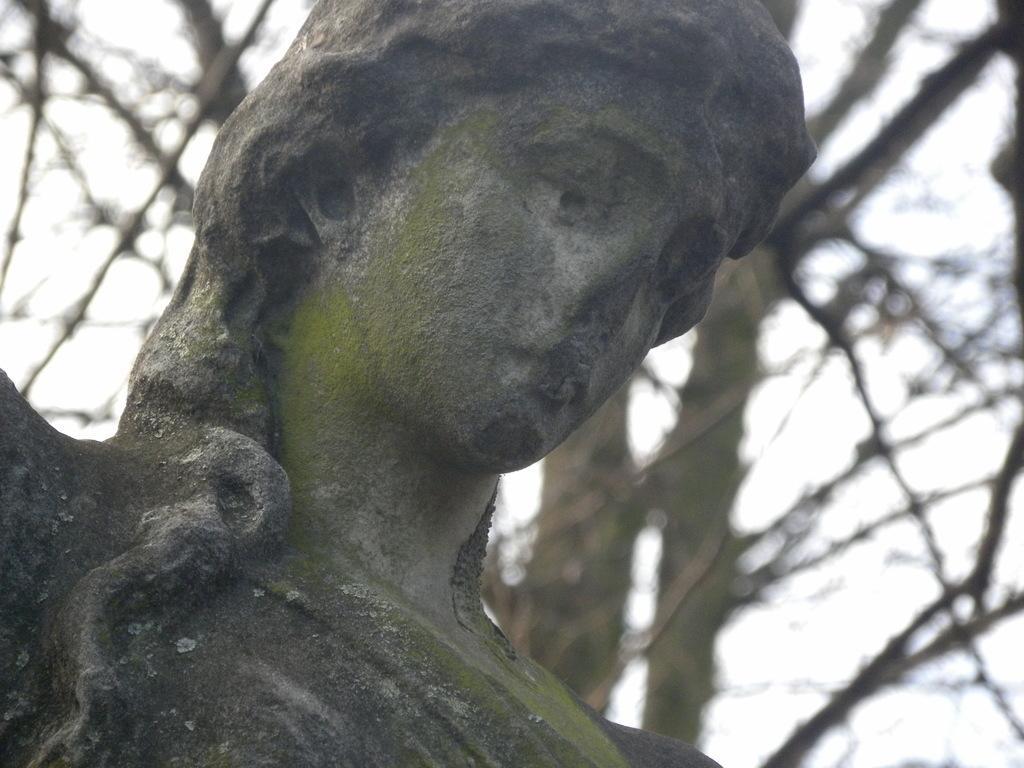In one or two sentences, can you explain what this image depicts? In this image we can see a statue. In the background there are trees and sky. 